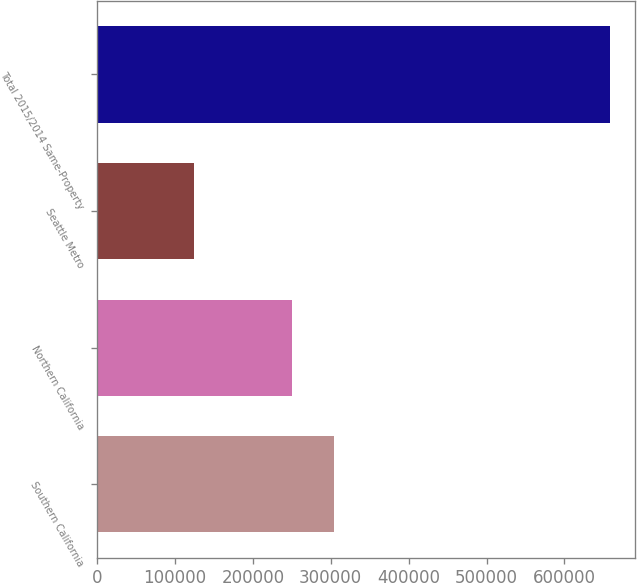Convert chart to OTSL. <chart><loc_0><loc_0><loc_500><loc_500><bar_chart><fcel>Southern California<fcel>Northern California<fcel>Seattle Metro<fcel>Total 2015/2014 Same-Property<nl><fcel>303869<fcel>250478<fcel>124143<fcel>658056<nl></chart> 